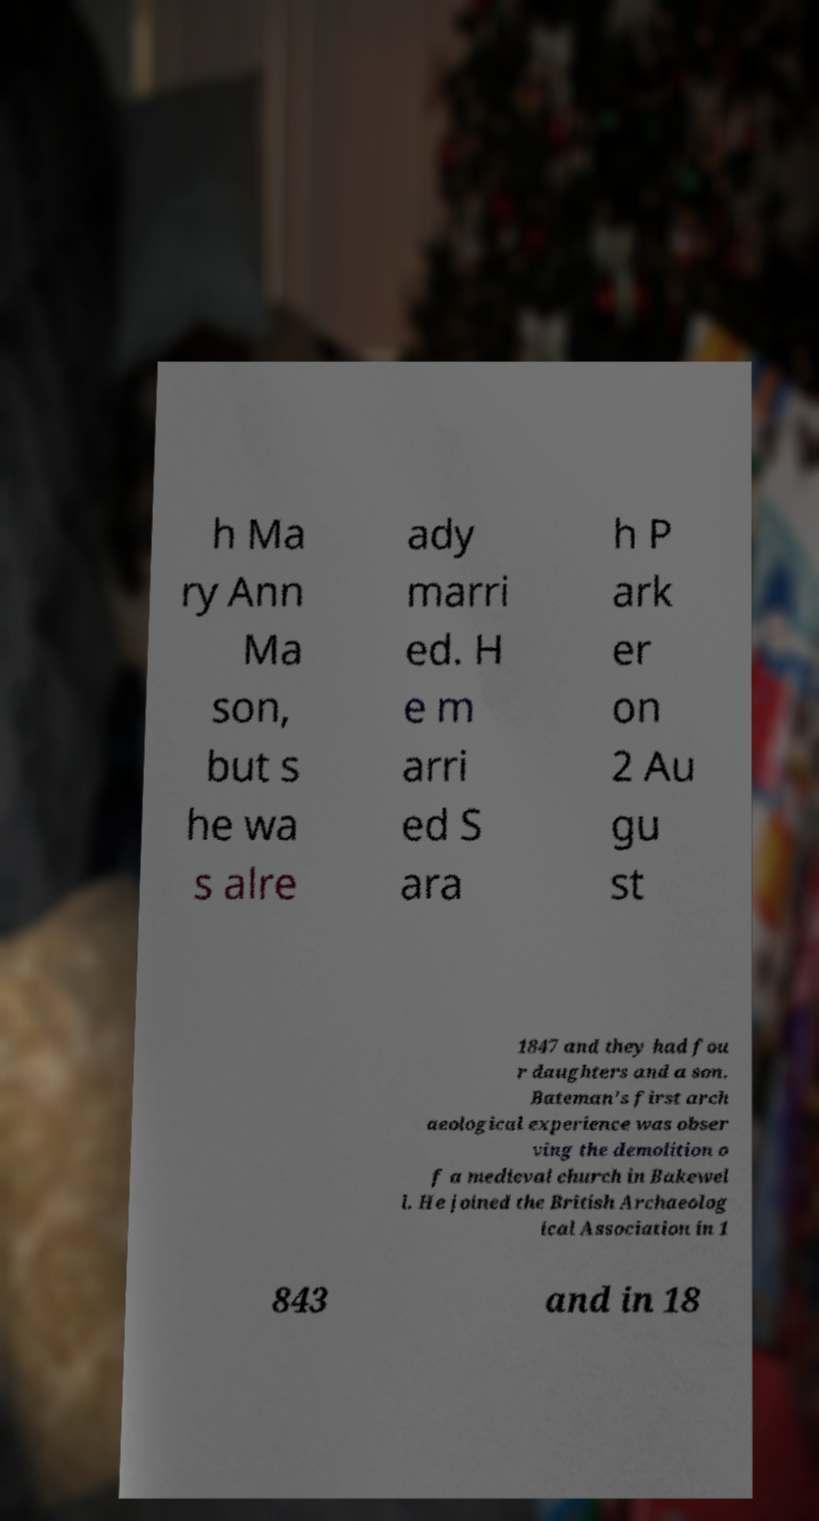Please identify and transcribe the text found in this image. h Ma ry Ann Ma son, but s he wa s alre ady marri ed. H e m arri ed S ara h P ark er on 2 Au gu st 1847 and they had fou r daughters and a son. Bateman's first arch aeological experience was obser ving the demolition o f a medieval church in Bakewel l. He joined the British Archaeolog ical Association in 1 843 and in 18 